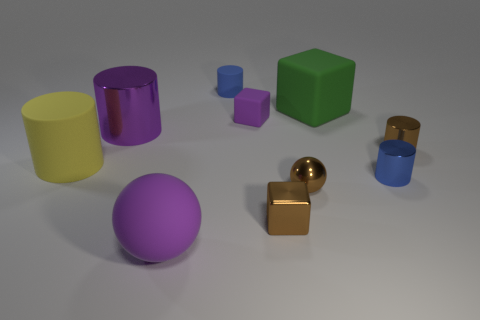Subtract all purple cylinders. How many cylinders are left? 4 Subtract all small blue rubber cylinders. How many cylinders are left? 4 Subtract all gray cylinders. Subtract all cyan spheres. How many cylinders are left? 5 Subtract all blocks. How many objects are left? 7 Subtract all tiny brown shiny blocks. Subtract all big purple metal cylinders. How many objects are left? 8 Add 9 small metallic spheres. How many small metallic spheres are left? 10 Add 4 big blue matte cylinders. How many big blue matte cylinders exist? 4 Subtract 0 yellow cubes. How many objects are left? 10 